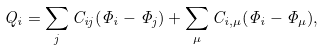<formula> <loc_0><loc_0><loc_500><loc_500>Q _ { i } = \sum _ { j } C _ { i j } ( \Phi _ { i } - \Phi _ { j } ) + \sum _ { \mu } C _ { i , \mu } ( \Phi _ { i } - \Phi _ { \mu } ) ,</formula> 